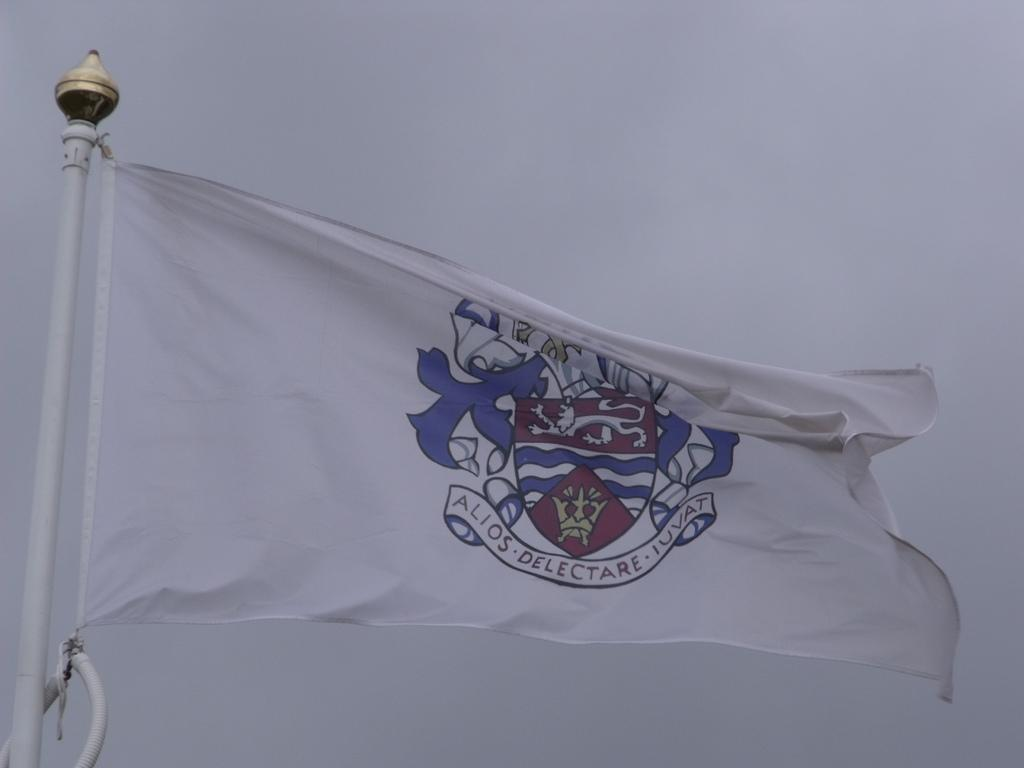What is located in the foreground of the image? There is a flag in the foreground of the image. What can be seen in the background of the image? The sky is visible in the background of the image. What type of toy can be seen in the image? There is no toy present in the image. What season is depicted in the image? The image does not depict a specific season, as there are no seasonal cues present. 